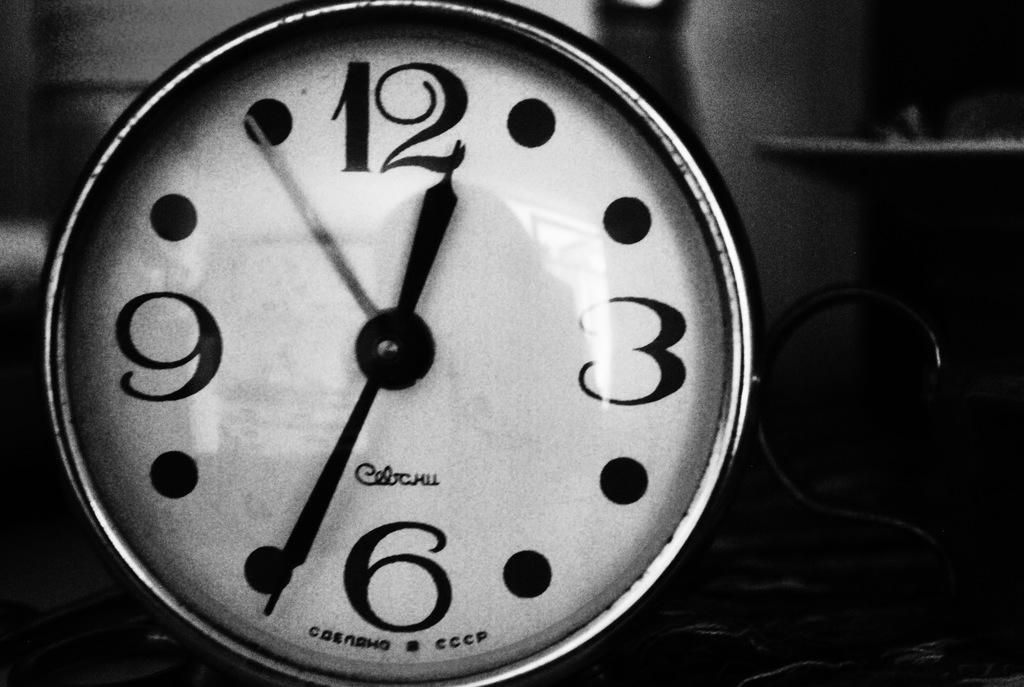Describe this image in one or two sentences. In this picture we can see a clock and in the background we can see it is dark. 